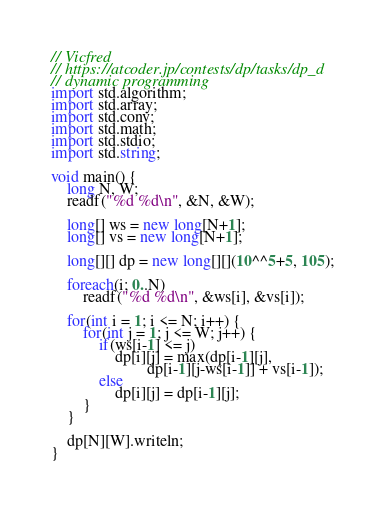<code> <loc_0><loc_0><loc_500><loc_500><_D_>// Vicfred
// https://atcoder.jp/contests/dp/tasks/dp_d
// dynamic programming
import std.algorithm;
import std.array;
import std.conv;
import std.math;
import std.stdio;
import std.string;

void main() {
    long N, W;
    readf("%d %d\n", &N, &W);

    long[] ws = new long[N+1];
    long[] vs = new long[N+1];

    long[][] dp = new long[][](10^^5+5, 105);

    foreach(i; 0..N)
        readf("%d %d\n", &ws[i], &vs[i]);

    for(int i = 1; i <= N; i++) {
        for(int j = 1; j <= W; j++) {
            if(ws[i-1] <= j)
                dp[i][j] = max(dp[i-1][j],
                        dp[i-1][j-ws[i-1]] + vs[i-1]);
            else
                dp[i][j] = dp[i-1][j];
        }
    }

    dp[N][W].writeln;
}


</code> 